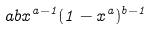<formula> <loc_0><loc_0><loc_500><loc_500>a b x ^ { a - 1 } ( 1 - x ^ { a } ) ^ { b - 1 }</formula> 